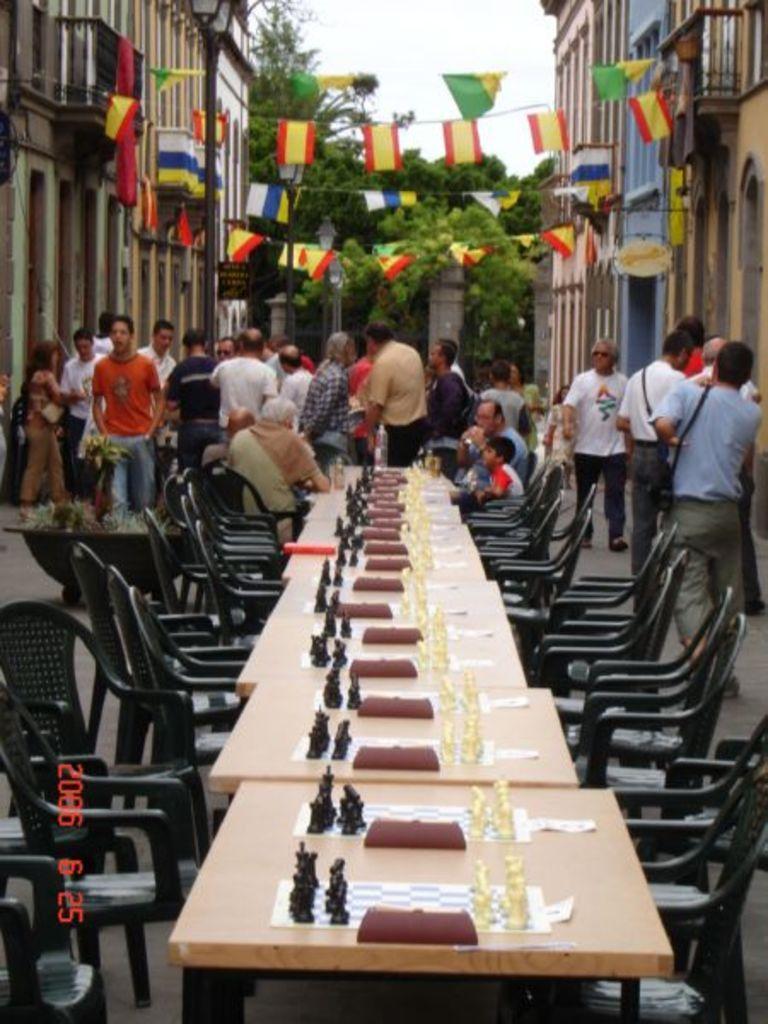Can you describe this image briefly? In this image In this I can see outside view of a city and there is a table on the middle and there are some chairs kept on the middle ,on the table there are some chess boards kept, on the right side and left side there are the person standing and there is a building visible on the right and left side and there is a sky and there are some trees visible on the middle and there are some flags visible and there are hanging through the wall 